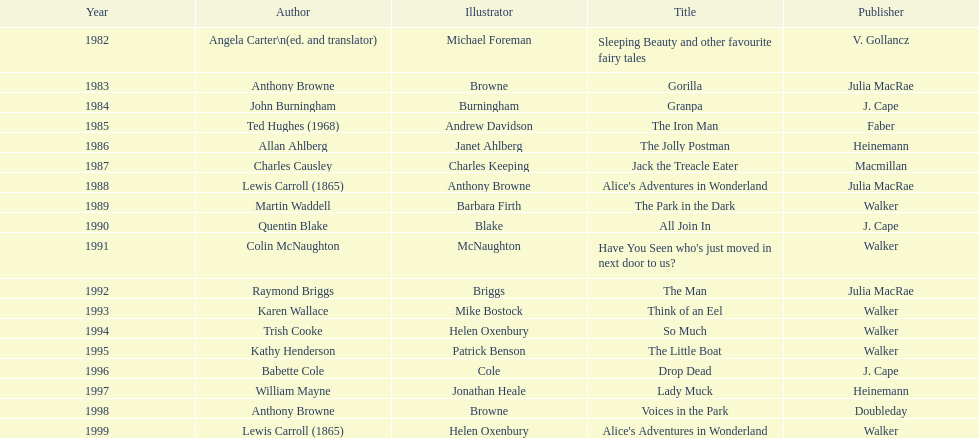What are the number of kurt maschler awards helen oxenbury has won? 2. Write the full table. {'header': ['Year', 'Author', 'Illustrator', 'Title', 'Publisher'], 'rows': [['1982', 'Angela Carter\\n(ed. and translator)', 'Michael Foreman', 'Sleeping Beauty and other favourite fairy tales', 'V. Gollancz'], ['1983', 'Anthony Browne', 'Browne', 'Gorilla', 'Julia MacRae'], ['1984', 'John Burningham', 'Burningham', 'Granpa', 'J. Cape'], ['1985', 'Ted Hughes (1968)', 'Andrew Davidson', 'The Iron Man', 'Faber'], ['1986', 'Allan Ahlberg', 'Janet Ahlberg', 'The Jolly Postman', 'Heinemann'], ['1987', 'Charles Causley', 'Charles Keeping', 'Jack the Treacle Eater', 'Macmillan'], ['1988', 'Lewis Carroll (1865)', 'Anthony Browne', "Alice's Adventures in Wonderland", 'Julia MacRae'], ['1989', 'Martin Waddell', 'Barbara Firth', 'The Park in the Dark', 'Walker'], ['1990', 'Quentin Blake', 'Blake', 'All Join In', 'J. Cape'], ['1991', 'Colin McNaughton', 'McNaughton', "Have You Seen who's just moved in next door to us?", 'Walker'], ['1992', 'Raymond Briggs', 'Briggs', 'The Man', 'Julia MacRae'], ['1993', 'Karen Wallace', 'Mike Bostock', 'Think of an Eel', 'Walker'], ['1994', 'Trish Cooke', 'Helen Oxenbury', 'So Much', 'Walker'], ['1995', 'Kathy Henderson', 'Patrick Benson', 'The Little Boat', 'Walker'], ['1996', 'Babette Cole', 'Cole', 'Drop Dead', 'J. Cape'], ['1997', 'William Mayne', 'Jonathan Heale', 'Lady Muck', 'Heinemann'], ['1998', 'Anthony Browne', 'Browne', 'Voices in the Park', 'Doubleday'], ['1999', 'Lewis Carroll (1865)', 'Helen Oxenbury', "Alice's Adventures in Wonderland", 'Walker']]} 